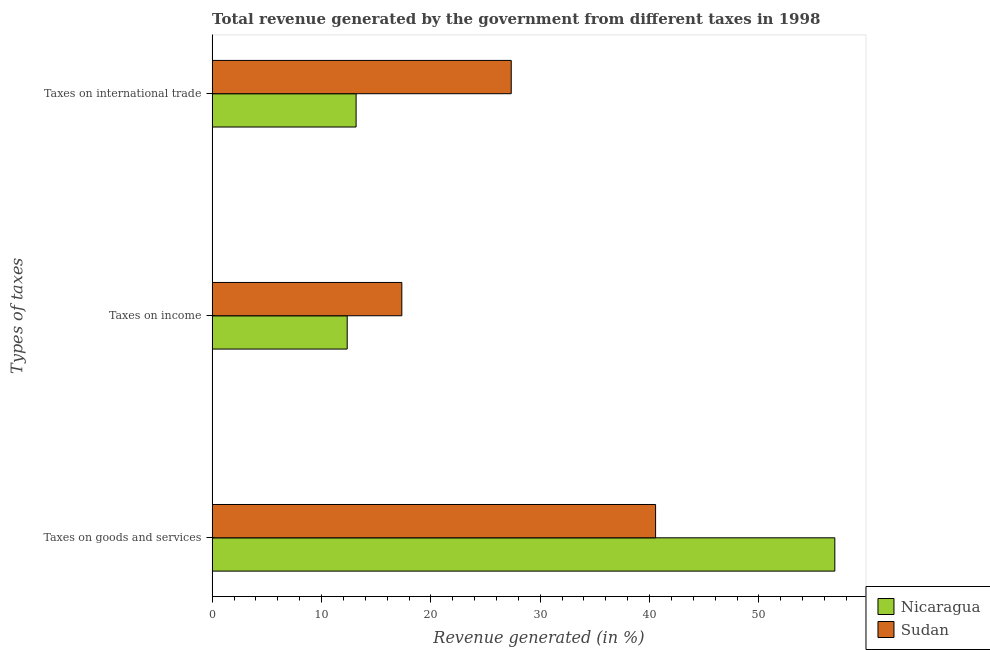How many bars are there on the 3rd tick from the bottom?
Ensure brevity in your answer.  2. What is the label of the 2nd group of bars from the top?
Provide a succinct answer. Taxes on income. What is the percentage of revenue generated by taxes on goods and services in Sudan?
Your answer should be very brief. 40.55. Across all countries, what is the maximum percentage of revenue generated by tax on international trade?
Your answer should be very brief. 27.35. Across all countries, what is the minimum percentage of revenue generated by tax on international trade?
Keep it short and to the point. 13.16. In which country was the percentage of revenue generated by tax on international trade maximum?
Offer a terse response. Sudan. In which country was the percentage of revenue generated by taxes on goods and services minimum?
Make the answer very short. Sudan. What is the total percentage of revenue generated by taxes on income in the graph?
Keep it short and to the point. 29.7. What is the difference between the percentage of revenue generated by tax on international trade in Sudan and that in Nicaragua?
Give a very brief answer. 14.18. What is the difference between the percentage of revenue generated by tax on international trade in Sudan and the percentage of revenue generated by taxes on income in Nicaragua?
Make the answer very short. 15. What is the average percentage of revenue generated by taxes on income per country?
Your answer should be very brief. 14.85. What is the difference between the percentage of revenue generated by taxes on income and percentage of revenue generated by taxes on goods and services in Nicaragua?
Keep it short and to the point. -44.58. What is the ratio of the percentage of revenue generated by taxes on income in Nicaragua to that in Sudan?
Offer a very short reply. 0.71. What is the difference between the highest and the second highest percentage of revenue generated by taxes on goods and services?
Offer a very short reply. 16.39. What is the difference between the highest and the lowest percentage of revenue generated by taxes on income?
Make the answer very short. 4.99. What does the 1st bar from the top in Taxes on income represents?
Provide a short and direct response. Sudan. What does the 1st bar from the bottom in Taxes on goods and services represents?
Your answer should be compact. Nicaragua. Is it the case that in every country, the sum of the percentage of revenue generated by taxes on goods and services and percentage of revenue generated by taxes on income is greater than the percentage of revenue generated by tax on international trade?
Provide a short and direct response. Yes. How many countries are there in the graph?
Offer a very short reply. 2. What is the difference between two consecutive major ticks on the X-axis?
Your answer should be compact. 10. Are the values on the major ticks of X-axis written in scientific E-notation?
Provide a short and direct response. No. Does the graph contain any zero values?
Make the answer very short. No. Where does the legend appear in the graph?
Offer a terse response. Bottom right. What is the title of the graph?
Make the answer very short. Total revenue generated by the government from different taxes in 1998. What is the label or title of the X-axis?
Give a very brief answer. Revenue generated (in %). What is the label or title of the Y-axis?
Offer a very short reply. Types of taxes. What is the Revenue generated (in %) of Nicaragua in Taxes on goods and services?
Offer a terse response. 56.93. What is the Revenue generated (in %) of Sudan in Taxes on goods and services?
Your answer should be very brief. 40.55. What is the Revenue generated (in %) in Nicaragua in Taxes on income?
Make the answer very short. 12.35. What is the Revenue generated (in %) of Sudan in Taxes on income?
Your answer should be very brief. 17.34. What is the Revenue generated (in %) of Nicaragua in Taxes on international trade?
Ensure brevity in your answer.  13.16. What is the Revenue generated (in %) of Sudan in Taxes on international trade?
Provide a short and direct response. 27.35. Across all Types of taxes, what is the maximum Revenue generated (in %) of Nicaragua?
Your answer should be compact. 56.93. Across all Types of taxes, what is the maximum Revenue generated (in %) in Sudan?
Keep it short and to the point. 40.55. Across all Types of taxes, what is the minimum Revenue generated (in %) in Nicaragua?
Give a very brief answer. 12.35. Across all Types of taxes, what is the minimum Revenue generated (in %) of Sudan?
Your answer should be compact. 17.34. What is the total Revenue generated (in %) of Nicaragua in the graph?
Your response must be concise. 82.45. What is the total Revenue generated (in %) of Sudan in the graph?
Make the answer very short. 85.24. What is the difference between the Revenue generated (in %) in Nicaragua in Taxes on goods and services and that in Taxes on income?
Offer a very short reply. 44.58. What is the difference between the Revenue generated (in %) of Sudan in Taxes on goods and services and that in Taxes on income?
Provide a succinct answer. 23.2. What is the difference between the Revenue generated (in %) in Nicaragua in Taxes on goods and services and that in Taxes on international trade?
Offer a very short reply. 43.77. What is the difference between the Revenue generated (in %) in Sudan in Taxes on goods and services and that in Taxes on international trade?
Your response must be concise. 13.2. What is the difference between the Revenue generated (in %) of Nicaragua in Taxes on income and that in Taxes on international trade?
Ensure brevity in your answer.  -0.81. What is the difference between the Revenue generated (in %) in Sudan in Taxes on income and that in Taxes on international trade?
Give a very brief answer. -10. What is the difference between the Revenue generated (in %) in Nicaragua in Taxes on goods and services and the Revenue generated (in %) in Sudan in Taxes on income?
Offer a very short reply. 39.59. What is the difference between the Revenue generated (in %) of Nicaragua in Taxes on goods and services and the Revenue generated (in %) of Sudan in Taxes on international trade?
Offer a terse response. 29.59. What is the difference between the Revenue generated (in %) of Nicaragua in Taxes on income and the Revenue generated (in %) of Sudan in Taxes on international trade?
Keep it short and to the point. -15. What is the average Revenue generated (in %) in Nicaragua per Types of taxes?
Offer a very short reply. 27.48. What is the average Revenue generated (in %) of Sudan per Types of taxes?
Provide a succinct answer. 28.41. What is the difference between the Revenue generated (in %) of Nicaragua and Revenue generated (in %) of Sudan in Taxes on goods and services?
Provide a short and direct response. 16.39. What is the difference between the Revenue generated (in %) in Nicaragua and Revenue generated (in %) in Sudan in Taxes on income?
Your answer should be compact. -4.99. What is the difference between the Revenue generated (in %) in Nicaragua and Revenue generated (in %) in Sudan in Taxes on international trade?
Give a very brief answer. -14.18. What is the ratio of the Revenue generated (in %) in Nicaragua in Taxes on goods and services to that in Taxes on income?
Keep it short and to the point. 4.61. What is the ratio of the Revenue generated (in %) in Sudan in Taxes on goods and services to that in Taxes on income?
Ensure brevity in your answer.  2.34. What is the ratio of the Revenue generated (in %) of Nicaragua in Taxes on goods and services to that in Taxes on international trade?
Ensure brevity in your answer.  4.32. What is the ratio of the Revenue generated (in %) in Sudan in Taxes on goods and services to that in Taxes on international trade?
Make the answer very short. 1.48. What is the ratio of the Revenue generated (in %) in Nicaragua in Taxes on income to that in Taxes on international trade?
Keep it short and to the point. 0.94. What is the ratio of the Revenue generated (in %) in Sudan in Taxes on income to that in Taxes on international trade?
Provide a succinct answer. 0.63. What is the difference between the highest and the second highest Revenue generated (in %) in Nicaragua?
Offer a very short reply. 43.77. What is the difference between the highest and the second highest Revenue generated (in %) in Sudan?
Your response must be concise. 13.2. What is the difference between the highest and the lowest Revenue generated (in %) in Nicaragua?
Ensure brevity in your answer.  44.58. What is the difference between the highest and the lowest Revenue generated (in %) in Sudan?
Provide a succinct answer. 23.2. 